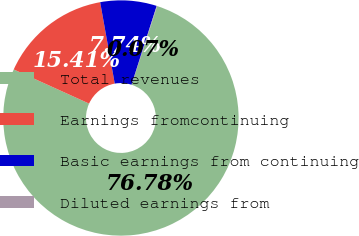Convert chart. <chart><loc_0><loc_0><loc_500><loc_500><pie_chart><fcel>Total revenues<fcel>Earnings fromcontinuing<fcel>Basic earnings from continuing<fcel>Diluted earnings from<nl><fcel>76.78%<fcel>15.41%<fcel>7.74%<fcel>0.07%<nl></chart> 